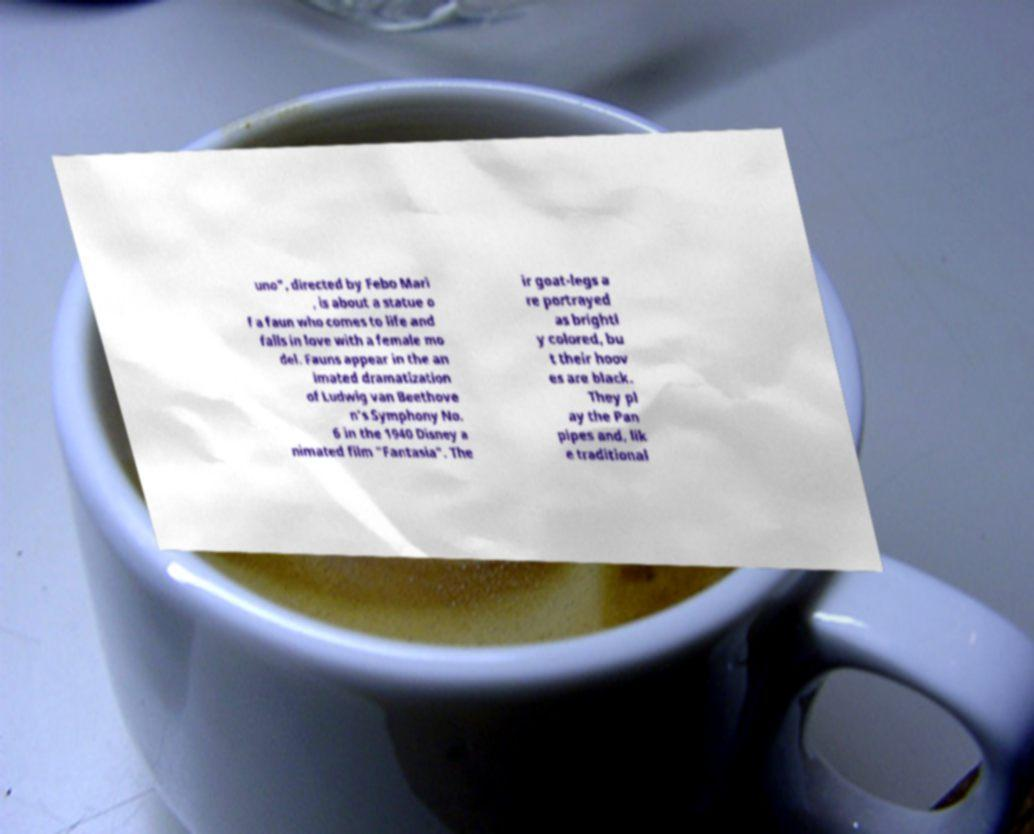Please read and relay the text visible in this image. What does it say? uno", directed by Febo Mari , is about a statue o f a faun who comes to life and falls in love with a female mo del. Fauns appear in the an imated dramatization of Ludwig van Beethove n's Symphony No. 6 in the 1940 Disney a nimated film "Fantasia". The ir goat-legs a re portrayed as brightl y colored, bu t their hoov es are black. They pl ay the Pan pipes and, lik e traditional 